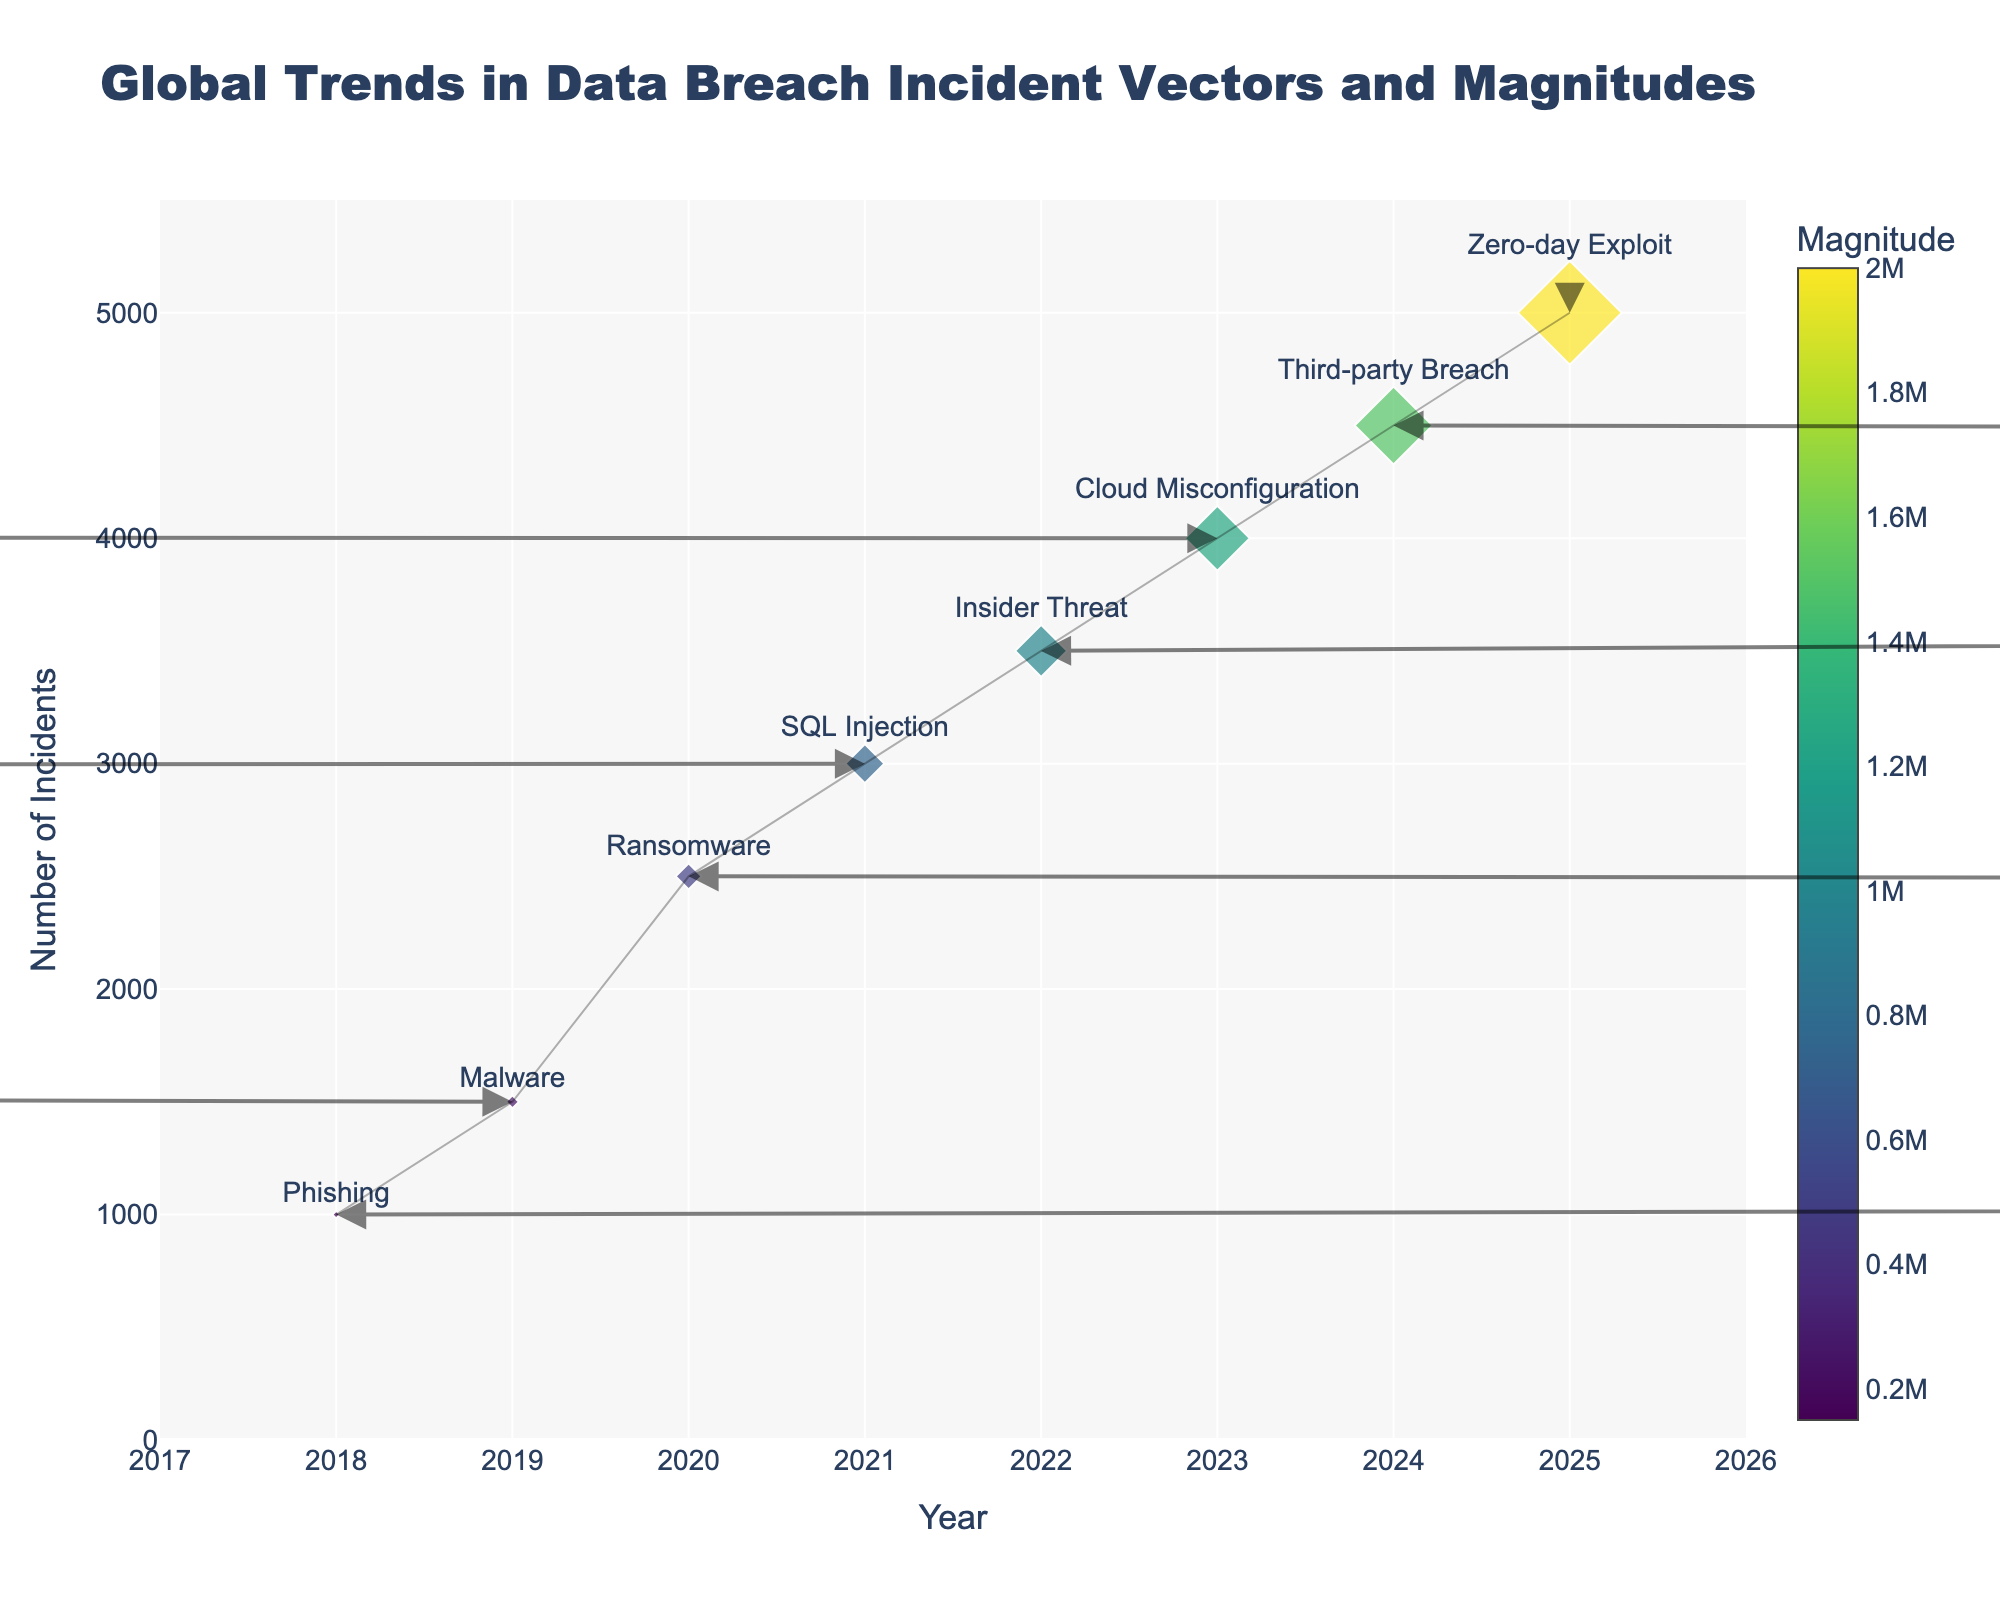what is the title of the figure? The title is at the top of the figure in larger, bold text. It reads "Global Trends in Data Breach Incident Vectors and Magnitudes."
Answer: Global Trends in Data Breach Incident Vectors and Magnitudes How many unique incident vectors are represented in the figure? The unique incident vectors are labeled next to each marker on the chart. They are: Phishing, Malware, Ransomware, SQL Injection, Insider Threat, Cloud Misconfiguration, Third-party Breach, Zero-day Exploit. Counting these labels gives us 8 unique incident vectors.
Answer: 8 Which year shows the highest number of incidents? The y-axis represents the number of incidents, and you can find the highest point on this axis to determine the year. The point at the highest y-value is at 5000 incidents, which corresponds to the year 2025.
Answer: 2025 What is the average magnitude of data breaches over the years presented? To find this, sum up all the magnitudes and divide by the number of years. The magnitudes are 150000, 250000, 500000, 750000, 1000000, 1250000, 1500000, 2000000. Their sum is 7400000, and there are 8 years, thus the average is 7400000 / 8 = 925000.
Answer: 925000 How did the magnitude of data breaches change from 2020 to 2021 for Ransomware and SQL Injection? In 2020, the magnitude for Ransomware is 500000, and in 2021 for SQL Injection, it is 750000. The change is 750000 - 500000 = 250000.
Answer: Increased by 250000 Which incident vector had the greatest positive horizontal displacement over the years? Displacement can be determined by the vector (u). The greatest positive horizontal displacement is observed when the u value is highest. Phishing has u=2, Third-party Breach also has u=2. Hence, both have the greatest positive horizontal displacement.
Answer: Phishing and Third-party Breach Compare the vectors for Phishing in 2018 and Cloud Misconfiguration in 2023 based on their u and v components. For Phishing in 2018, u=2 and v=3. For Cloud Misconfiguration in 2023, u=-3 and v=1. Comparatively, Phishing has higher upward (v) displacement, while Cloud Misconfiguration has a higher negative (u) horizontal displacement.
Answer: Phishing has higher upward and Cloud Misconfiguration has higher negative horizontal What's the general trend in the magnitude of data breaches from 2018 to 2025? Looking at the marker sizes which correspond to the magnitude and the color that scales with magnitude, it is apparent that the sizes and darker colors increase from 2018 to 2025. This indicates an increasing trend in the magnitude of data breaches over the years.
Answer: Increasing trend Which incident vector has the smallest magnitude and in what year? The magnitudes are indicated by the size and color on the plot, and the magnitude is shown on hover text. The smallest magnitude of 150000 corresponds to Phishing in the year 2018.
Answer: Phishing in 2018 In what year did Number of Incidents for Insider Threat reach its peak? The y-axis represents the number of incidents. Locate the point for Insider Threat which has a tag and see its vertical position. Insider Threat is at its peak in the year 2022 with 3500 incidents.
Answer: 2022 